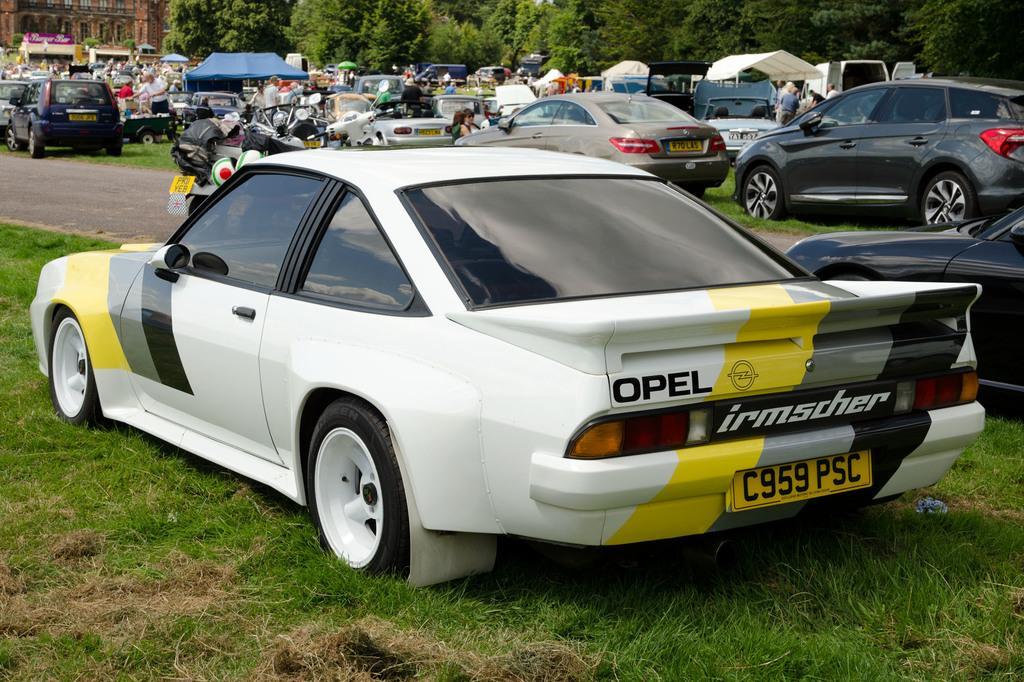Could you give a brief overview of what you see in this image? In this image we can see motor vehicles on the ground, parasols, persons standing on the ground, buildings and trees. 